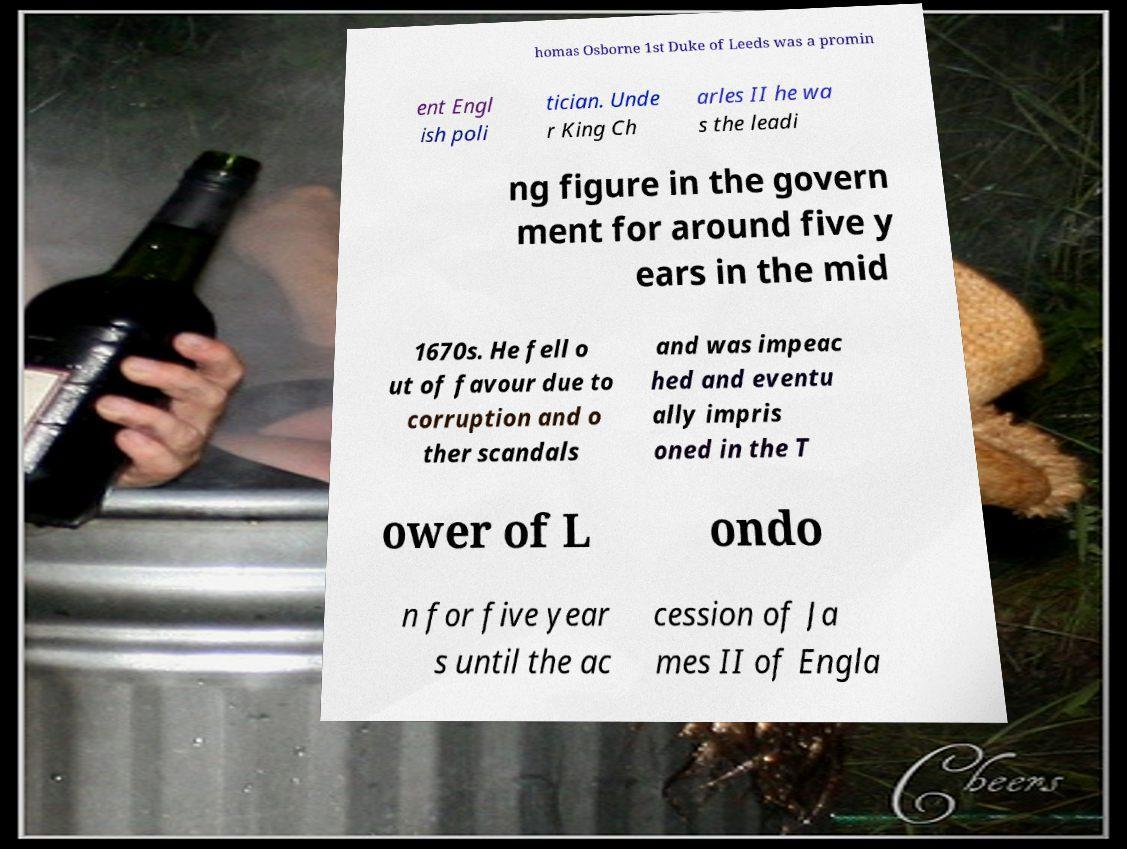Could you extract and type out the text from this image? homas Osborne 1st Duke of Leeds was a promin ent Engl ish poli tician. Unde r King Ch arles II he wa s the leadi ng figure in the govern ment for around five y ears in the mid 1670s. He fell o ut of favour due to corruption and o ther scandals and was impeac hed and eventu ally impris oned in the T ower of L ondo n for five year s until the ac cession of Ja mes II of Engla 